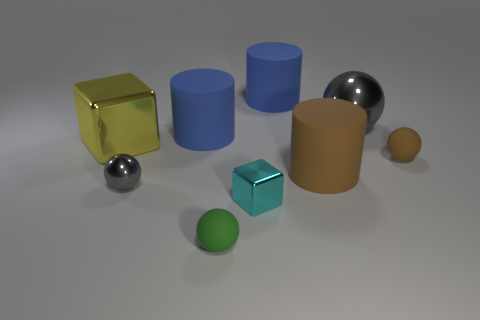Subtract all purple cylinders. Subtract all green blocks. How many cylinders are left? 3 Add 1 blue metal objects. How many objects exist? 10 Subtract all cylinders. How many objects are left? 6 Add 6 big metallic objects. How many big metallic objects are left? 8 Add 3 small rubber objects. How many small rubber objects exist? 5 Subtract 1 brown cylinders. How many objects are left? 8 Subtract all tiny rubber balls. Subtract all large matte cylinders. How many objects are left? 4 